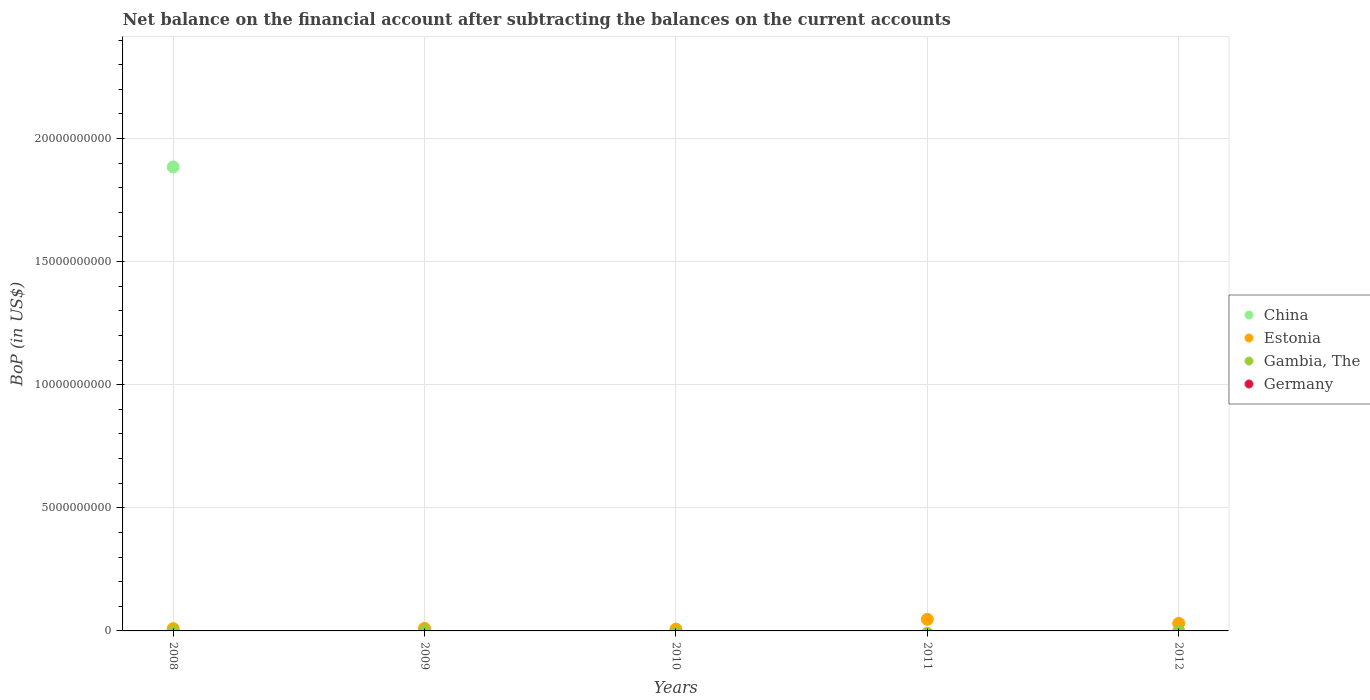Is the number of dotlines equal to the number of legend labels?
Your answer should be very brief. No. What is the Balance of Payments in Germany in 2009?
Make the answer very short. 0. Across all years, what is the maximum Balance of Payments in China?
Give a very brief answer. 1.88e+1. In which year was the Balance of Payments in Estonia maximum?
Give a very brief answer. 2011. What is the total Balance of Payments in China in the graph?
Provide a short and direct response. 1.88e+1. What is the difference between the Balance of Payments in Estonia in 2008 and that in 2011?
Offer a very short reply. -3.80e+08. What is the difference between the Balance of Payments in Estonia in 2010 and the Balance of Payments in Gambia, The in 2012?
Provide a short and direct response. 7.18e+07. What is the average Balance of Payments in Germany per year?
Make the answer very short. 0. In the year 2009, what is the difference between the Balance of Payments in Gambia, The and Balance of Payments in Estonia?
Provide a short and direct response. -9.45e+07. In how many years, is the Balance of Payments in China greater than 23000000000 US$?
Offer a terse response. 0. What is the ratio of the Balance of Payments in Estonia in 2010 to that in 2011?
Your answer should be very brief. 0.15. Is the Balance of Payments in Estonia in 2008 less than that in 2011?
Ensure brevity in your answer.  Yes. What is the difference between the highest and the lowest Balance of Payments in Estonia?
Offer a terse response. 4.00e+08. Is the sum of the Balance of Payments in Estonia in 2010 and 2012 greater than the maximum Balance of Payments in Germany across all years?
Offer a very short reply. Yes. Is it the case that in every year, the sum of the Balance of Payments in Germany and Balance of Payments in Estonia  is greater than the sum of Balance of Payments in China and Balance of Payments in Gambia, The?
Make the answer very short. No. Does the Balance of Payments in Estonia monotonically increase over the years?
Your answer should be very brief. No. Is the Balance of Payments in Germany strictly greater than the Balance of Payments in China over the years?
Make the answer very short. No. Are the values on the major ticks of Y-axis written in scientific E-notation?
Give a very brief answer. No. Does the graph contain any zero values?
Provide a short and direct response. Yes. Does the graph contain grids?
Your answer should be compact. Yes. Where does the legend appear in the graph?
Your response must be concise. Center right. How are the legend labels stacked?
Offer a terse response. Vertical. What is the title of the graph?
Make the answer very short. Net balance on the financial account after subtracting the balances on the current accounts. Does "Afghanistan" appear as one of the legend labels in the graph?
Keep it short and to the point. No. What is the label or title of the X-axis?
Give a very brief answer. Years. What is the label or title of the Y-axis?
Provide a short and direct response. BoP (in US$). What is the BoP (in US$) of China in 2008?
Keep it short and to the point. 1.88e+1. What is the BoP (in US$) in Estonia in 2008?
Provide a short and direct response. 9.13e+07. What is the BoP (in US$) of Gambia, The in 2008?
Offer a terse response. 0. What is the BoP (in US$) of Estonia in 2009?
Provide a succinct answer. 1.02e+08. What is the BoP (in US$) of Gambia, The in 2009?
Keep it short and to the point. 7.24e+06. What is the BoP (in US$) in Germany in 2009?
Ensure brevity in your answer.  0. What is the BoP (in US$) of Estonia in 2010?
Offer a very short reply. 7.18e+07. What is the BoP (in US$) in Gambia, The in 2010?
Offer a very short reply. 0. What is the BoP (in US$) of Germany in 2010?
Make the answer very short. 0. What is the BoP (in US$) of Estonia in 2011?
Your answer should be very brief. 4.71e+08. What is the BoP (in US$) of Gambia, The in 2011?
Offer a terse response. 0. What is the BoP (in US$) in Estonia in 2012?
Offer a very short reply. 3.06e+08. What is the BoP (in US$) of Gambia, The in 2012?
Give a very brief answer. 0. Across all years, what is the maximum BoP (in US$) in China?
Provide a short and direct response. 1.88e+1. Across all years, what is the maximum BoP (in US$) in Estonia?
Provide a succinct answer. 4.71e+08. Across all years, what is the maximum BoP (in US$) of Gambia, The?
Provide a short and direct response. 7.24e+06. Across all years, what is the minimum BoP (in US$) of China?
Ensure brevity in your answer.  0. Across all years, what is the minimum BoP (in US$) in Estonia?
Offer a very short reply. 7.18e+07. Across all years, what is the minimum BoP (in US$) in Gambia, The?
Your answer should be very brief. 0. What is the total BoP (in US$) in China in the graph?
Keep it short and to the point. 1.88e+1. What is the total BoP (in US$) of Estonia in the graph?
Make the answer very short. 1.04e+09. What is the total BoP (in US$) in Gambia, The in the graph?
Provide a succinct answer. 7.24e+06. What is the total BoP (in US$) of Germany in the graph?
Ensure brevity in your answer.  0. What is the difference between the BoP (in US$) of Estonia in 2008 and that in 2009?
Ensure brevity in your answer.  -1.04e+07. What is the difference between the BoP (in US$) in Estonia in 2008 and that in 2010?
Your answer should be very brief. 1.96e+07. What is the difference between the BoP (in US$) of Estonia in 2008 and that in 2011?
Provide a short and direct response. -3.80e+08. What is the difference between the BoP (in US$) of Estonia in 2008 and that in 2012?
Provide a short and direct response. -2.15e+08. What is the difference between the BoP (in US$) of Estonia in 2009 and that in 2010?
Make the answer very short. 3.00e+07. What is the difference between the BoP (in US$) of Estonia in 2009 and that in 2011?
Keep it short and to the point. -3.70e+08. What is the difference between the BoP (in US$) of Estonia in 2009 and that in 2012?
Your answer should be very brief. -2.04e+08. What is the difference between the BoP (in US$) in Estonia in 2010 and that in 2011?
Provide a succinct answer. -4.00e+08. What is the difference between the BoP (in US$) of Estonia in 2010 and that in 2012?
Your answer should be very brief. -2.34e+08. What is the difference between the BoP (in US$) in Estonia in 2011 and that in 2012?
Your answer should be very brief. 1.65e+08. What is the difference between the BoP (in US$) of China in 2008 and the BoP (in US$) of Estonia in 2009?
Offer a terse response. 1.87e+1. What is the difference between the BoP (in US$) of China in 2008 and the BoP (in US$) of Gambia, The in 2009?
Ensure brevity in your answer.  1.88e+1. What is the difference between the BoP (in US$) of Estonia in 2008 and the BoP (in US$) of Gambia, The in 2009?
Offer a very short reply. 8.41e+07. What is the difference between the BoP (in US$) of China in 2008 and the BoP (in US$) of Estonia in 2010?
Provide a succinct answer. 1.88e+1. What is the difference between the BoP (in US$) of China in 2008 and the BoP (in US$) of Estonia in 2011?
Provide a short and direct response. 1.84e+1. What is the difference between the BoP (in US$) of China in 2008 and the BoP (in US$) of Estonia in 2012?
Ensure brevity in your answer.  1.85e+1. What is the average BoP (in US$) of China per year?
Offer a very short reply. 3.77e+09. What is the average BoP (in US$) in Estonia per year?
Provide a short and direct response. 2.08e+08. What is the average BoP (in US$) of Gambia, The per year?
Ensure brevity in your answer.  1.45e+06. In the year 2008, what is the difference between the BoP (in US$) in China and BoP (in US$) in Estonia?
Ensure brevity in your answer.  1.88e+1. In the year 2009, what is the difference between the BoP (in US$) in Estonia and BoP (in US$) in Gambia, The?
Offer a terse response. 9.45e+07. What is the ratio of the BoP (in US$) of Estonia in 2008 to that in 2009?
Offer a terse response. 0.9. What is the ratio of the BoP (in US$) of Estonia in 2008 to that in 2010?
Make the answer very short. 1.27. What is the ratio of the BoP (in US$) of Estonia in 2008 to that in 2011?
Keep it short and to the point. 0.19. What is the ratio of the BoP (in US$) of Estonia in 2008 to that in 2012?
Ensure brevity in your answer.  0.3. What is the ratio of the BoP (in US$) of Estonia in 2009 to that in 2010?
Keep it short and to the point. 1.42. What is the ratio of the BoP (in US$) of Estonia in 2009 to that in 2011?
Your answer should be compact. 0.22. What is the ratio of the BoP (in US$) in Estonia in 2009 to that in 2012?
Keep it short and to the point. 0.33. What is the ratio of the BoP (in US$) in Estonia in 2010 to that in 2011?
Ensure brevity in your answer.  0.15. What is the ratio of the BoP (in US$) of Estonia in 2010 to that in 2012?
Offer a very short reply. 0.23. What is the ratio of the BoP (in US$) in Estonia in 2011 to that in 2012?
Make the answer very short. 1.54. What is the difference between the highest and the second highest BoP (in US$) of Estonia?
Offer a very short reply. 1.65e+08. What is the difference between the highest and the lowest BoP (in US$) in China?
Provide a succinct answer. 1.88e+1. What is the difference between the highest and the lowest BoP (in US$) of Estonia?
Give a very brief answer. 4.00e+08. What is the difference between the highest and the lowest BoP (in US$) in Gambia, The?
Your answer should be compact. 7.24e+06. 